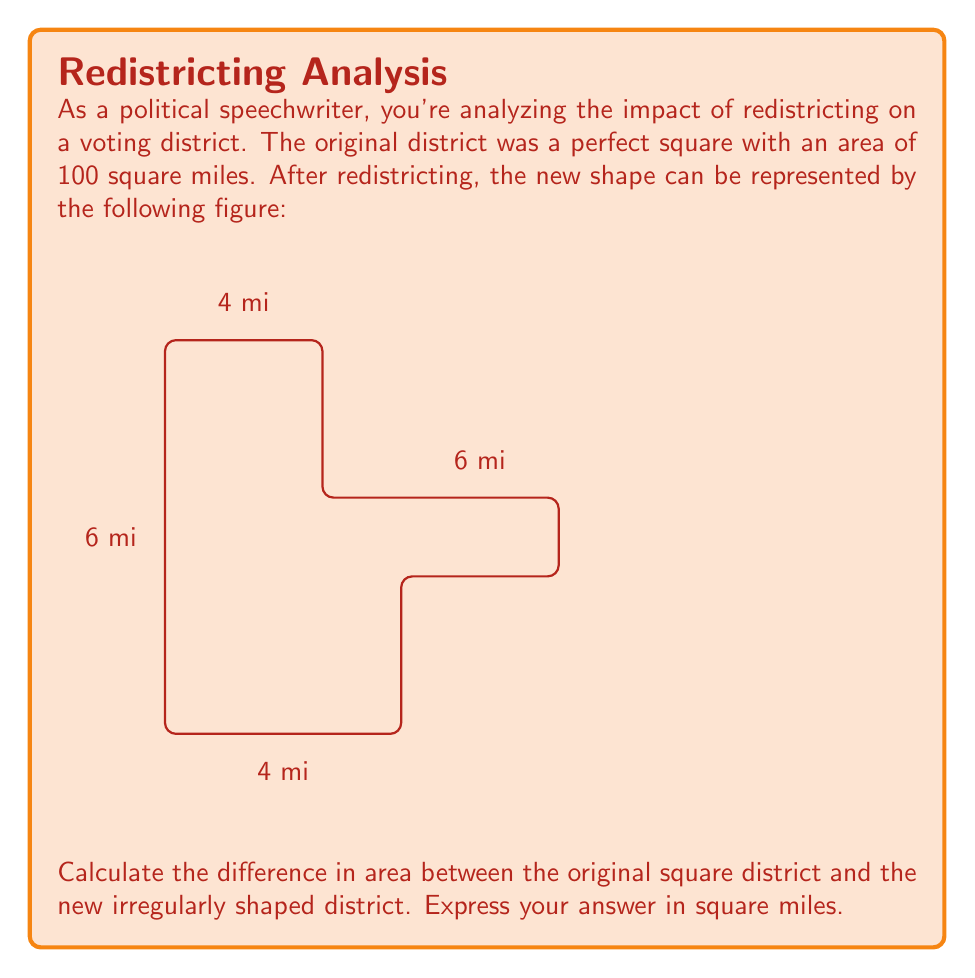What is the answer to this math problem? Let's approach this step-by-step:

1) First, let's recall the area of the original district:
   Original area = 100 square miles

2) Now, let's calculate the area of the new district:
   The new district can be divided into three rectangles:
   
   a) Left rectangle: 6 mi × 10 mi = 60 sq mi
   b) Upper right rectangle: 4 mi × 6 mi = 24 sq mi
   c) Lower right rectangle: 4 mi × 4 mi = 16 sq mi

3) Total area of the new district:
   $$ A_{new} = 60 + 24 + 16 = 100 \text{ sq mi} $$

4) To find the difference, we subtract:
   $$ \text{Difference} = A_{original} - A_{new} = 100 - 100 = 0 \text{ sq mi} $$

Interestingly, despite the change in shape, the area remains the same. This could be a point to highlight in a speech about how redistricting doesn't always change the size of a district, but can significantly alter its composition.
Answer: 0 sq mi 